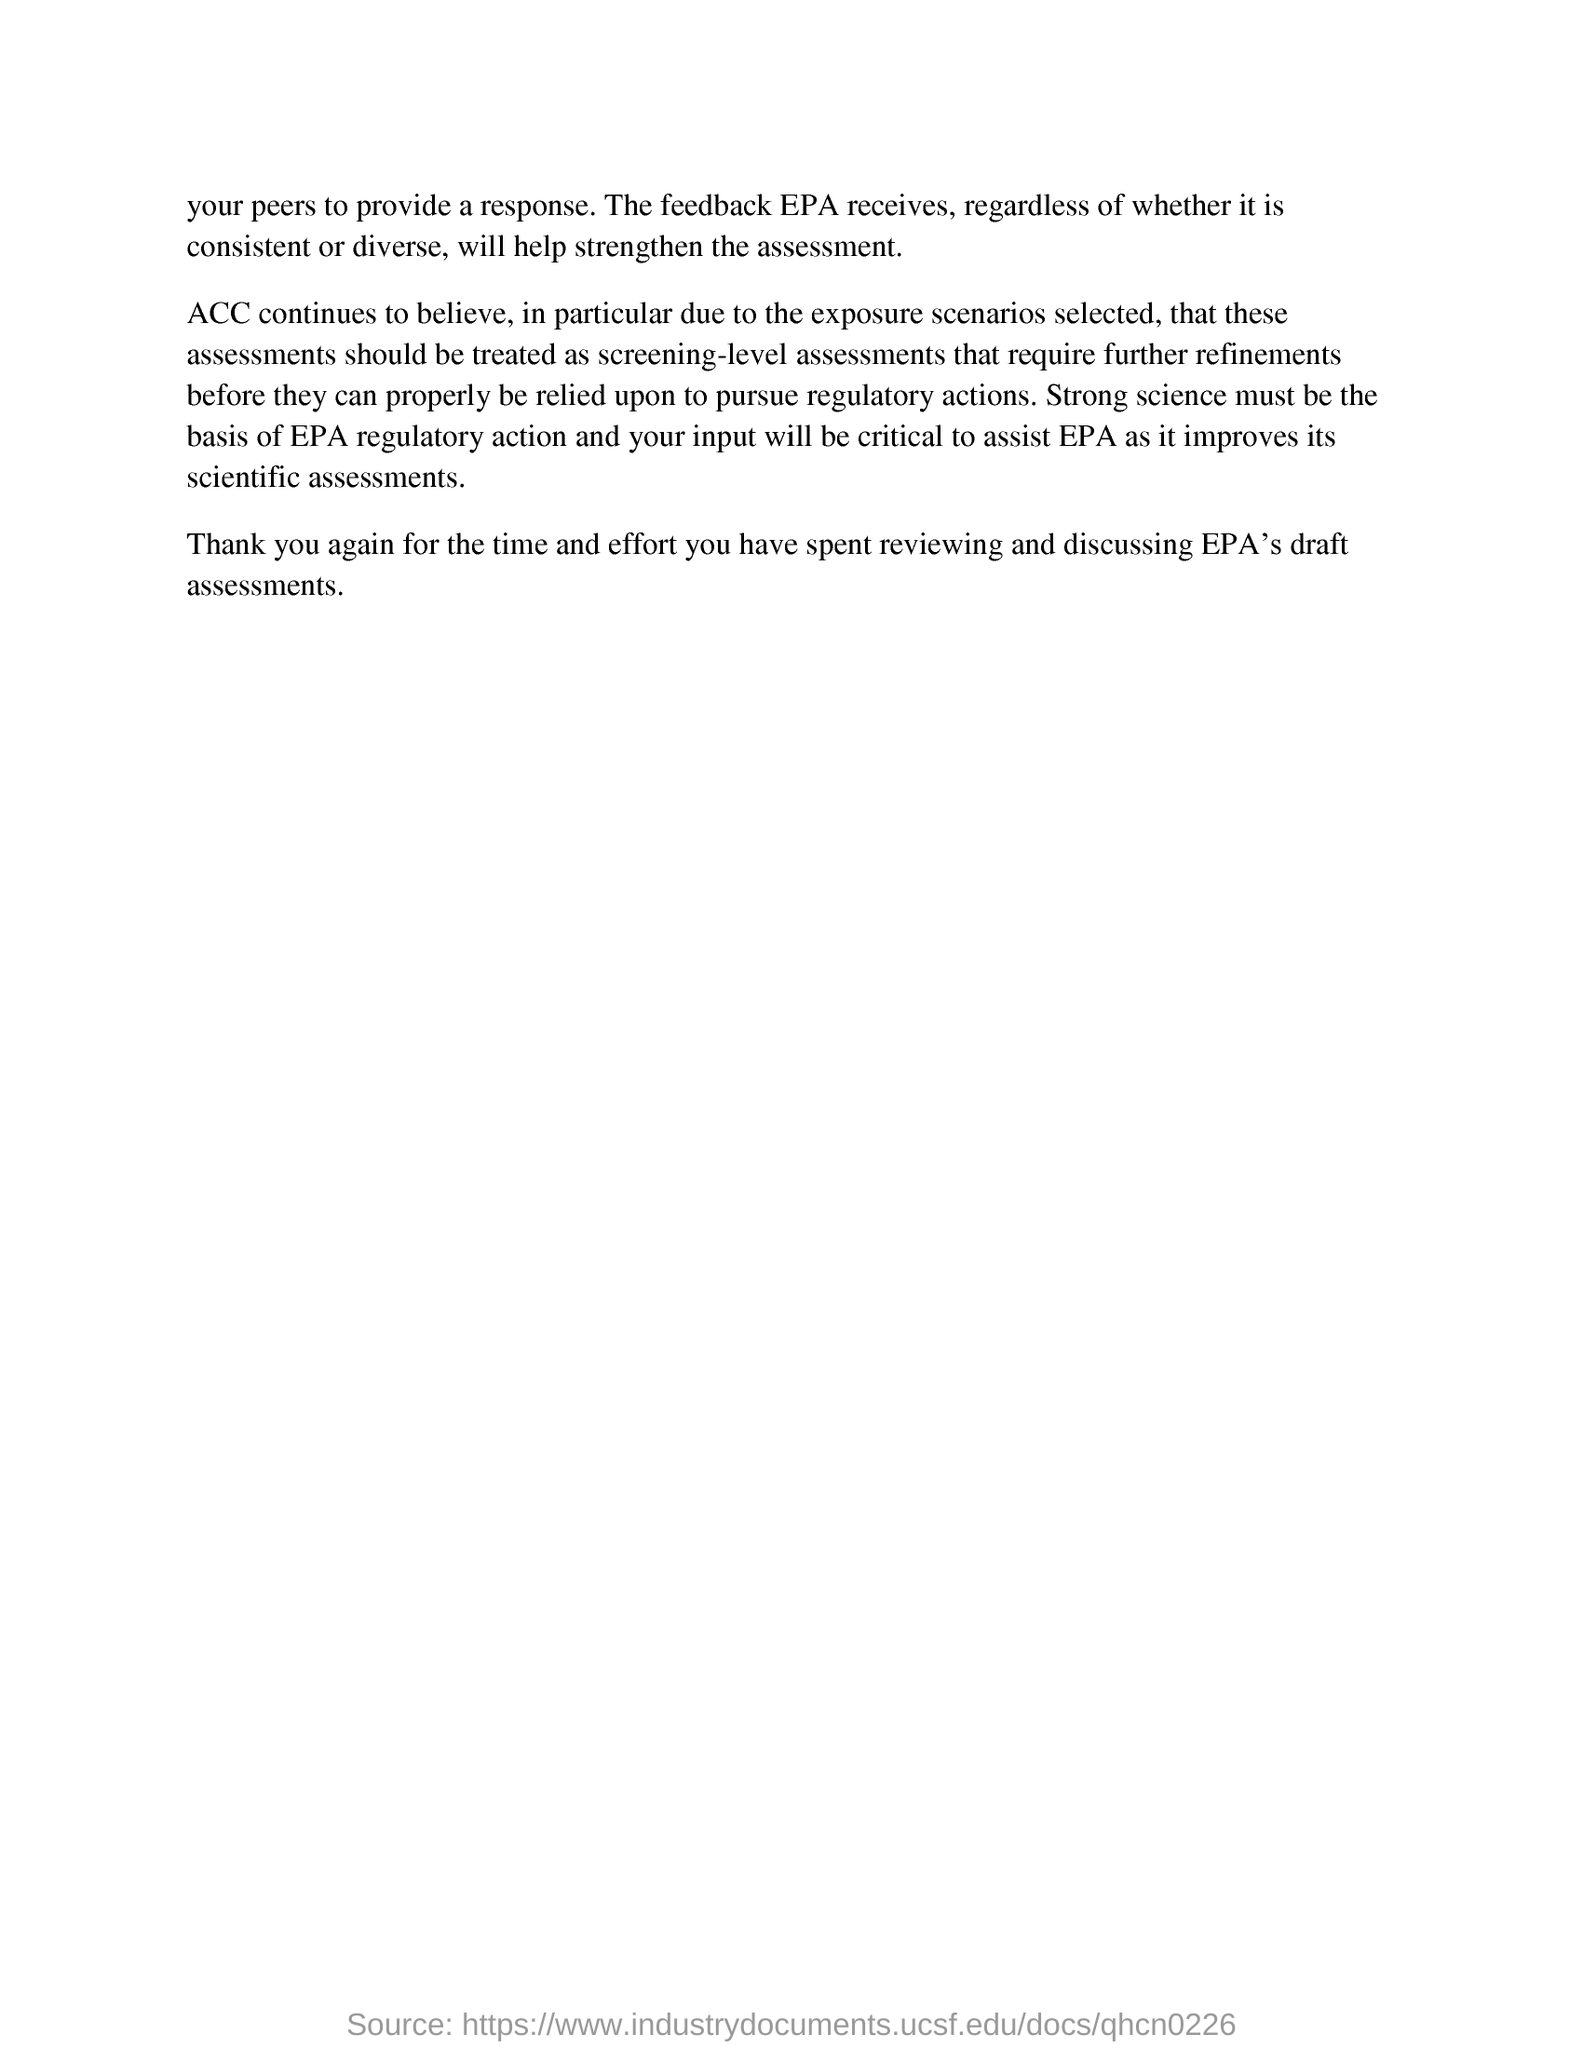Outline some significant characteristics in this image. The basis for EPA regulatory action should be strong science, which is critical in ensuring that decisions are based on the best available evidence and in protecting the health and environment of the American people. 